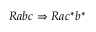Convert formula to latex. <formula><loc_0><loc_0><loc_500><loc_500>R a b c \Rightarrow R a c ^ { * } b ^ { * }</formula> 